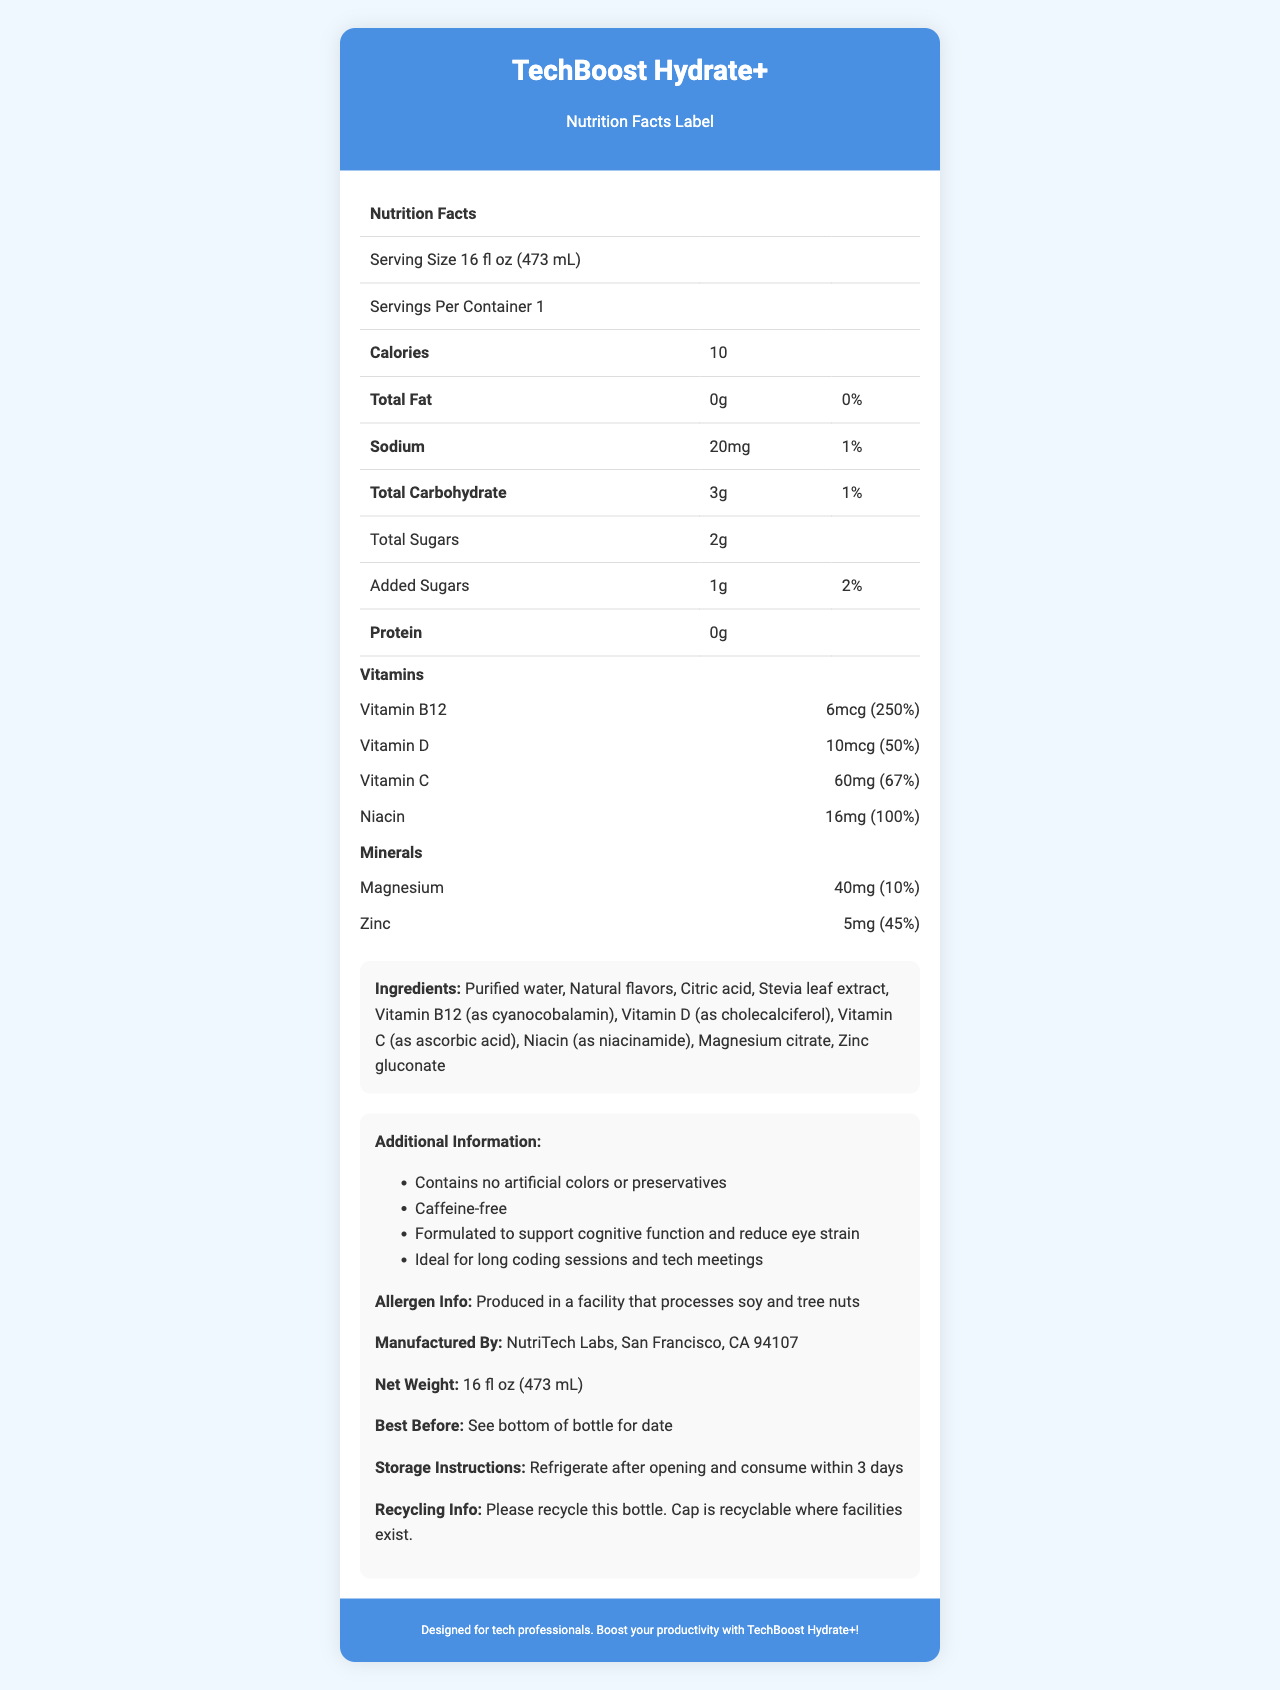what is the serving size for TechBoost Hydrate+? The serving size is clearly listed at the top of the nutrition facts table as "Serving Size 16 fl oz (473 mL)".
Answer: 16 fl oz (473 mL) how many calories are in one serving of TechBoost Hydrate+? The calories per serving are prominently displayed in the nutrition facts table as "Calories 10".
Answer: 10 calories what is the amount of total carbohydrates in one serving? The nutrition facts table lists "Total Carbohydrate 3g".
Answer: 3g which vitamins are included in TechBoost Hydrate+ and their respective % Daily Values? The document specifies the vitamins and their daily values: Vitamin B12 (250%), Vitamin D (50%), Vitamin C (67%), and Niacin (100%).
Answer: Vitamin B12: 250%, Vitamin D: 50%, Vitamin C: 67%, Niacin: 100% does TechBoost Hydrate+ contain protein? The document indicates "Protein 0g," which means it contains no protein.
Answer: No which ingredient is not listed in TechBoost Hydrate+? A. Vitamin B6 B. Stevia leaf extract C. Citric acid The listed ingredients include "Stevia leaf extract" and "Citric acid" but do not mention Vitamin B6.
Answer: A what company manufactures TechBoost Hydrate+? A. Hydration Labs B. NutriTech Labs C. Vitaboost Corp The document states "Manufactured By: NutriTech Labs, San Francisco, CA 94107."
Answer: B how many servings are there per container? The nutrition facts table specifies "Servings Per Container 1".
Answer: 1 is TechBoost Hydrate+ caffeine-free? The additional information section clearly mentions "Caffeine-free".
Answer: Yes what is the main idea of the document? The document is structured to provide comprehensive nutritional information about TechBoost Hydrate+, emphasizing its health benefits and suitability for tech professionals.
Answer: The main idea is to present the nutrition facts and benefits of TechBoost Hydrate+, a vitamin-infused water designed for tech professionals, including details about the calories, vitamins, ingredients, and additional information about the product. how much Zinc is in each serving and what is its % Daily Value? In the minerals section, the document lists Zinc with an amount of 5mg and a daily value of 45%.
Answer: 5mg, 45% is the recycling cap recyclable where facilities exist? The recycling information section states, "Cap is recyclable where facilities exist."
Answer: Yes how should TechBoost Hydrate+ be stored after opening? The storage instructions specify to refrigerate after opening and consume within 3 days.
Answer: Refrigerate after opening and consume within 3 days what is the best before date for TechBoost Hydrate+? The document states, "See bottom of bottle for date," which means the exact date is not provided in the document.
Answer: Cannot be determined 